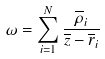Convert formula to latex. <formula><loc_0><loc_0><loc_500><loc_500>\omega = \sum _ { i = 1 } ^ { N } \frac { \overline { \rho } _ { i } } { \overline { z } - \overline { r } _ { i } }</formula> 